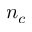Convert formula to latex. <formula><loc_0><loc_0><loc_500><loc_500>n _ { c }</formula> 